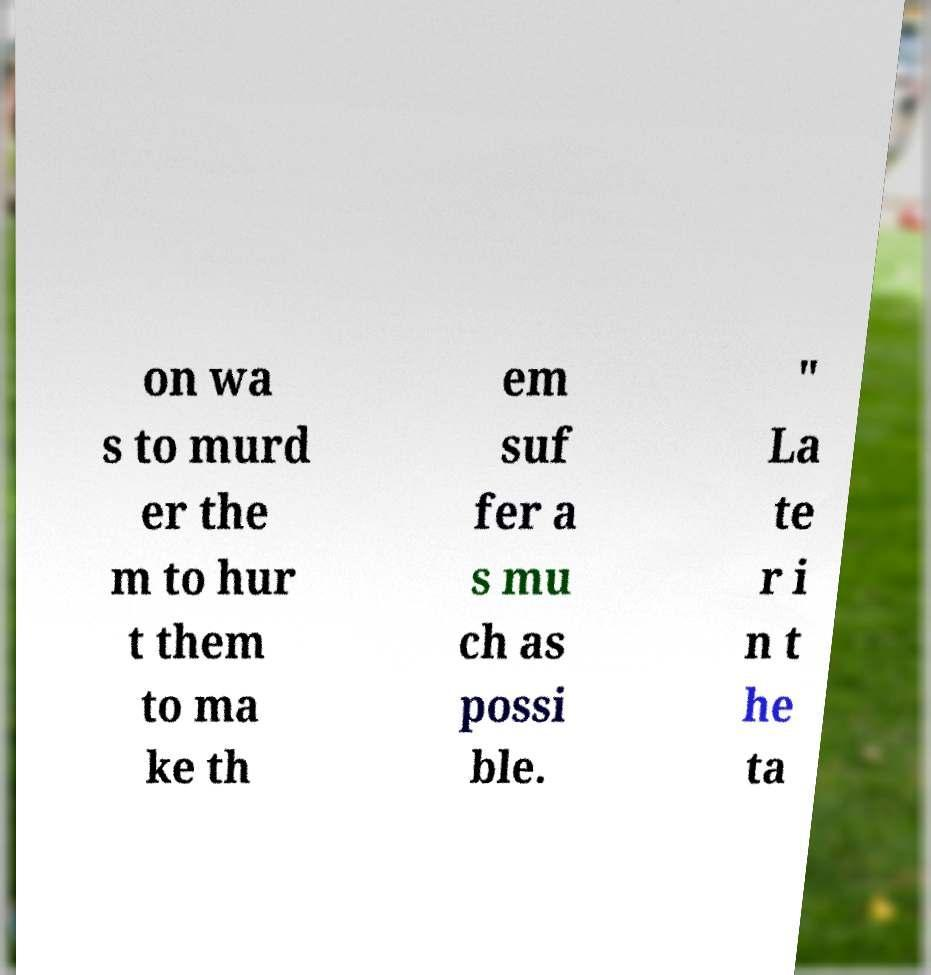There's text embedded in this image that I need extracted. Can you transcribe it verbatim? on wa s to murd er the m to hur t them to ma ke th em suf fer a s mu ch as possi ble. " La te r i n t he ta 